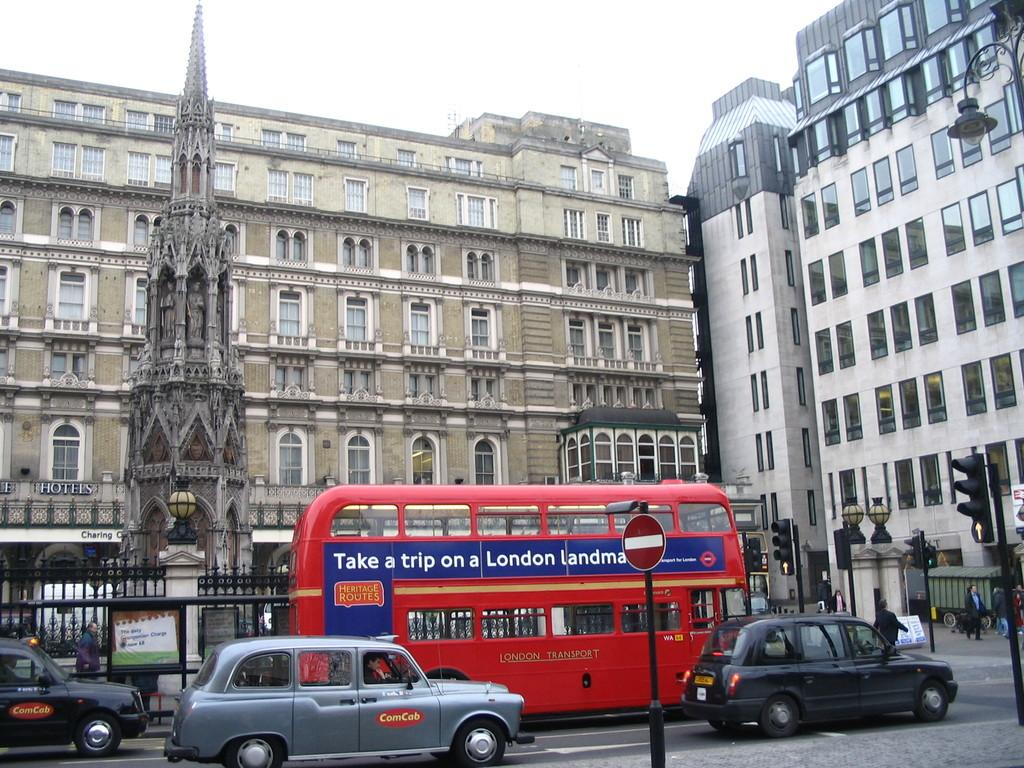<image>
Relay a brief, clear account of the picture shown. british street with silver comcab and red double decker bus advising to take a trip on a london landmark 